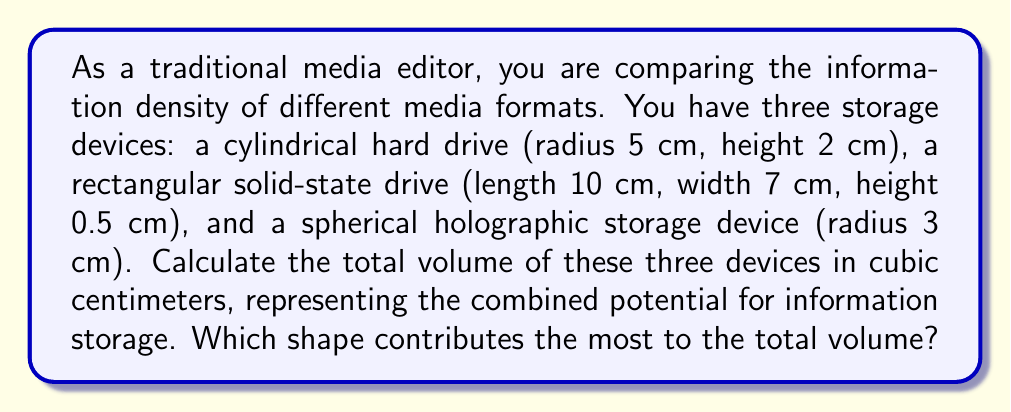Can you solve this math problem? To solve this problem, we need to calculate the volume of each shape and then sum them up. Let's break it down step by step:

1. Cylindrical hard drive:
   The volume of a cylinder is given by $V = \pi r^2 h$
   where $r$ is the radius and $h$ is the height.
   $$V_{cylinder} = \pi \cdot 5^2 \cdot 2 = 50\pi \approx 157.08 \text{ cm}^3$$

2. Rectangular solid-state drive:
   The volume of a rectangular solid is given by $V = l \cdot w \cdot h$
   where $l$ is length, $w$ is width, and $h$ is height.
   $$V_{rectangle} = 10 \cdot 7 \cdot 0.5 = 35 \text{ cm}^3$$

3. Spherical holographic storage device:
   The volume of a sphere is given by $V = \frac{4}{3}\pi r^3$
   where $r$ is the radius.
   $$V_{sphere} = \frac{4}{3}\pi \cdot 3^3 = 36\pi \approx 113.10 \text{ cm}^3$$

Now, let's sum up the volumes:
$$V_{total} = V_{cylinder} + V_{rectangle} + V_{sphere}$$
$$V_{total} = 50\pi + 35 + 36\pi = 86\pi + 35 \approx 305.18 \text{ cm}^3$$

To determine which shape contributes the most to the total volume, we compare the individual volumes:
- Cylinder: $157.08 \text{ cm}^3$
- Rectangle: $35 \text{ cm}^3$
- Sphere: $113.10 \text{ cm}^3$

The cylindrical hard drive contributes the most to the total volume.
Answer: The total volume of the three storage devices is $86\pi + 35 \approx 305.18 \text{ cm}^3$. The cylindrical hard drive contributes the most to the total volume. 